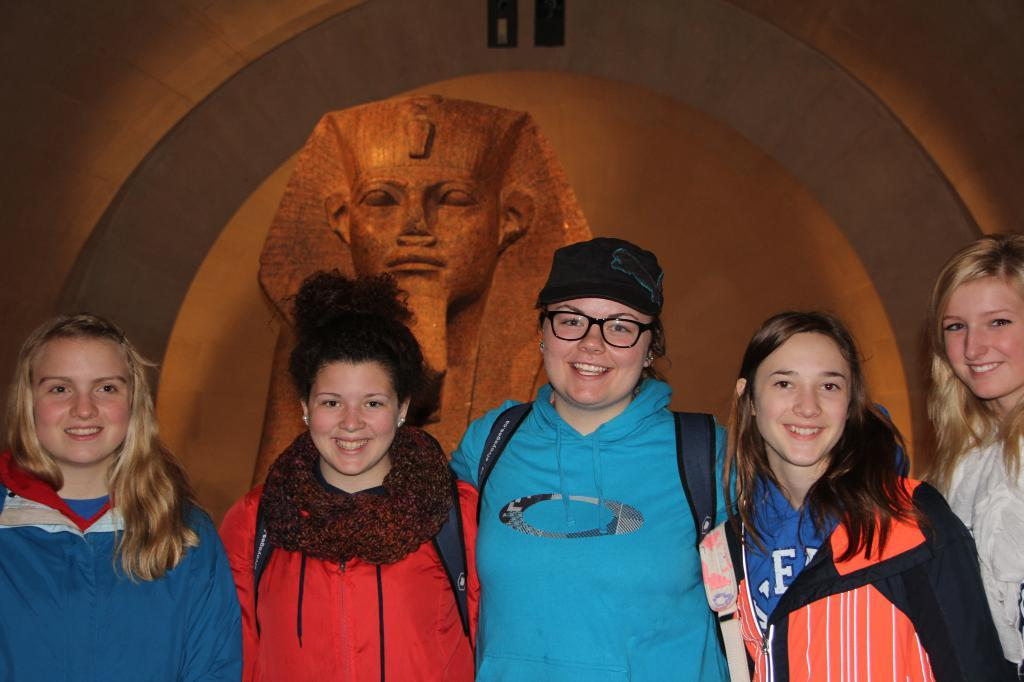Who is the main subject in the image? There is a woman standing in the middle of the image. What is the woman doing in the image? The woman is smiling. What is the woman wearing in the image? The woman is wearing a blue color sweater. Are there any other people in the image? Yes, there are other women standing beside her. What are the other women doing in the image? The other women are also smiling. What can be seen in the background of the image? There is an Egypt statue in the background of the image. Where is the drain located in the image? There is no drain present in the image. What type of spot can be seen on the woman's sweater in the image? There is no spot visible on the woman's sweater in the image. 